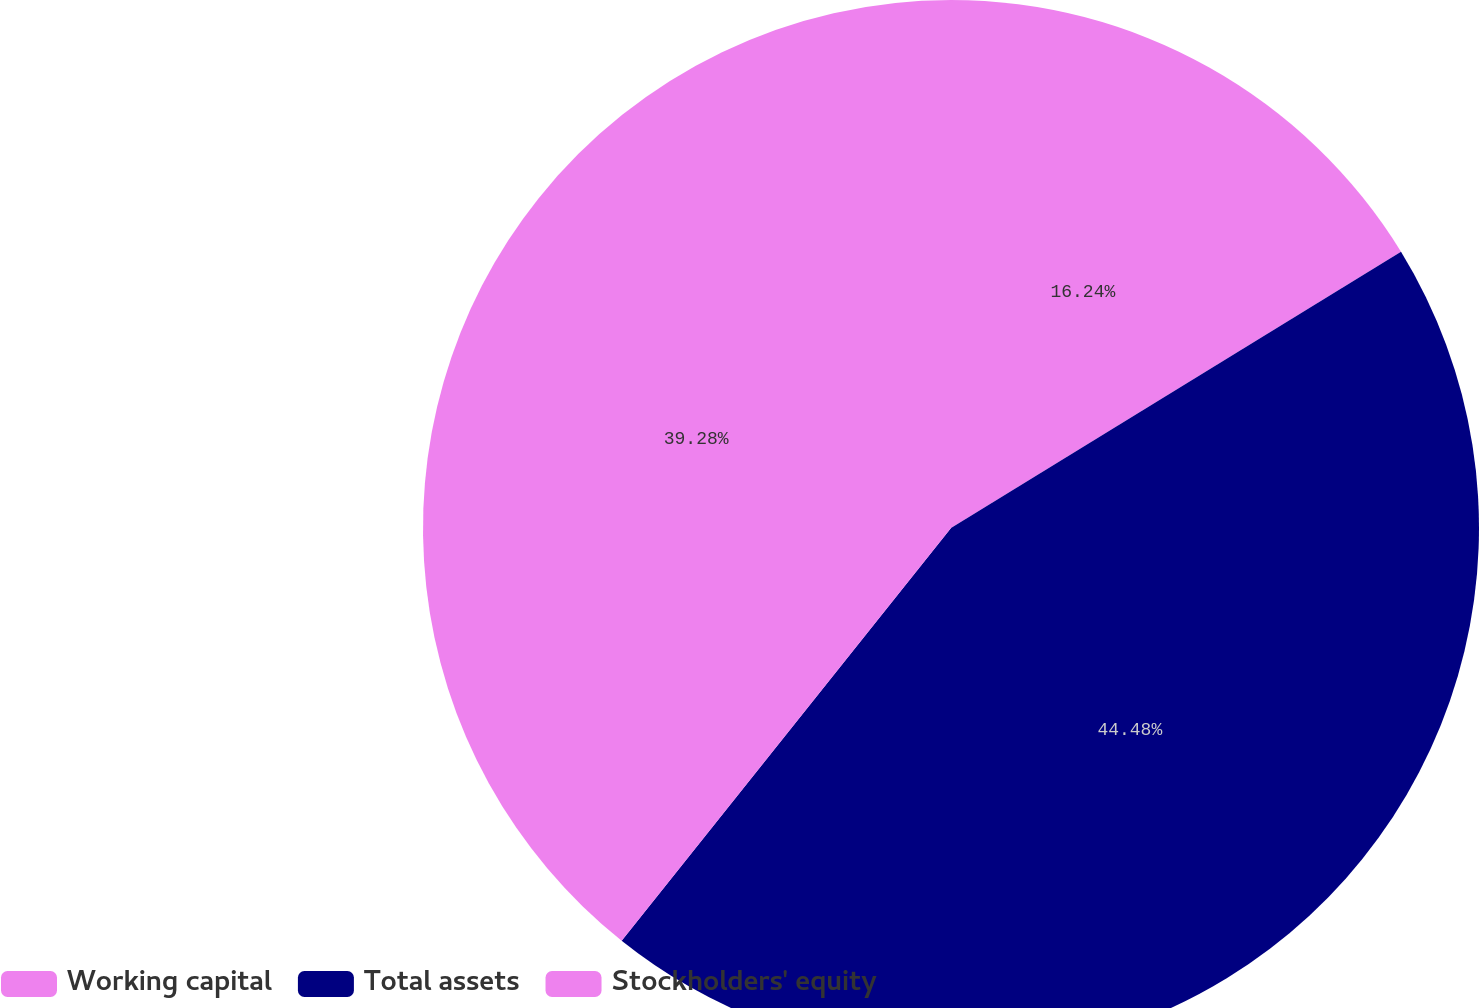Convert chart to OTSL. <chart><loc_0><loc_0><loc_500><loc_500><pie_chart><fcel>Working capital<fcel>Total assets<fcel>Stockholders' equity<nl><fcel>16.24%<fcel>44.48%<fcel>39.28%<nl></chart> 